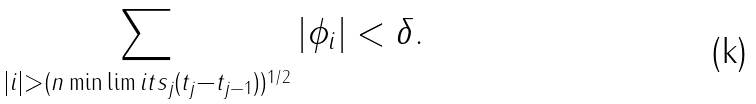Convert formula to latex. <formula><loc_0><loc_0><loc_500><loc_500>\sum _ { | i | > ( n \min \lim i t s _ { j } ( t _ { j } - t _ { j - 1 } ) ) ^ { 1 / 2 } } | \phi _ { i } | < \delta .</formula> 